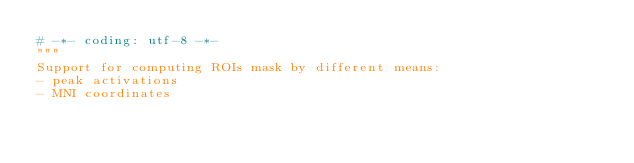Convert code to text. <code><loc_0><loc_0><loc_500><loc_500><_Python_># -*- coding: utf-8 -*-
"""
Support for computing ROIs mask by different means:
- peak activations
- MNI coordinates</code> 